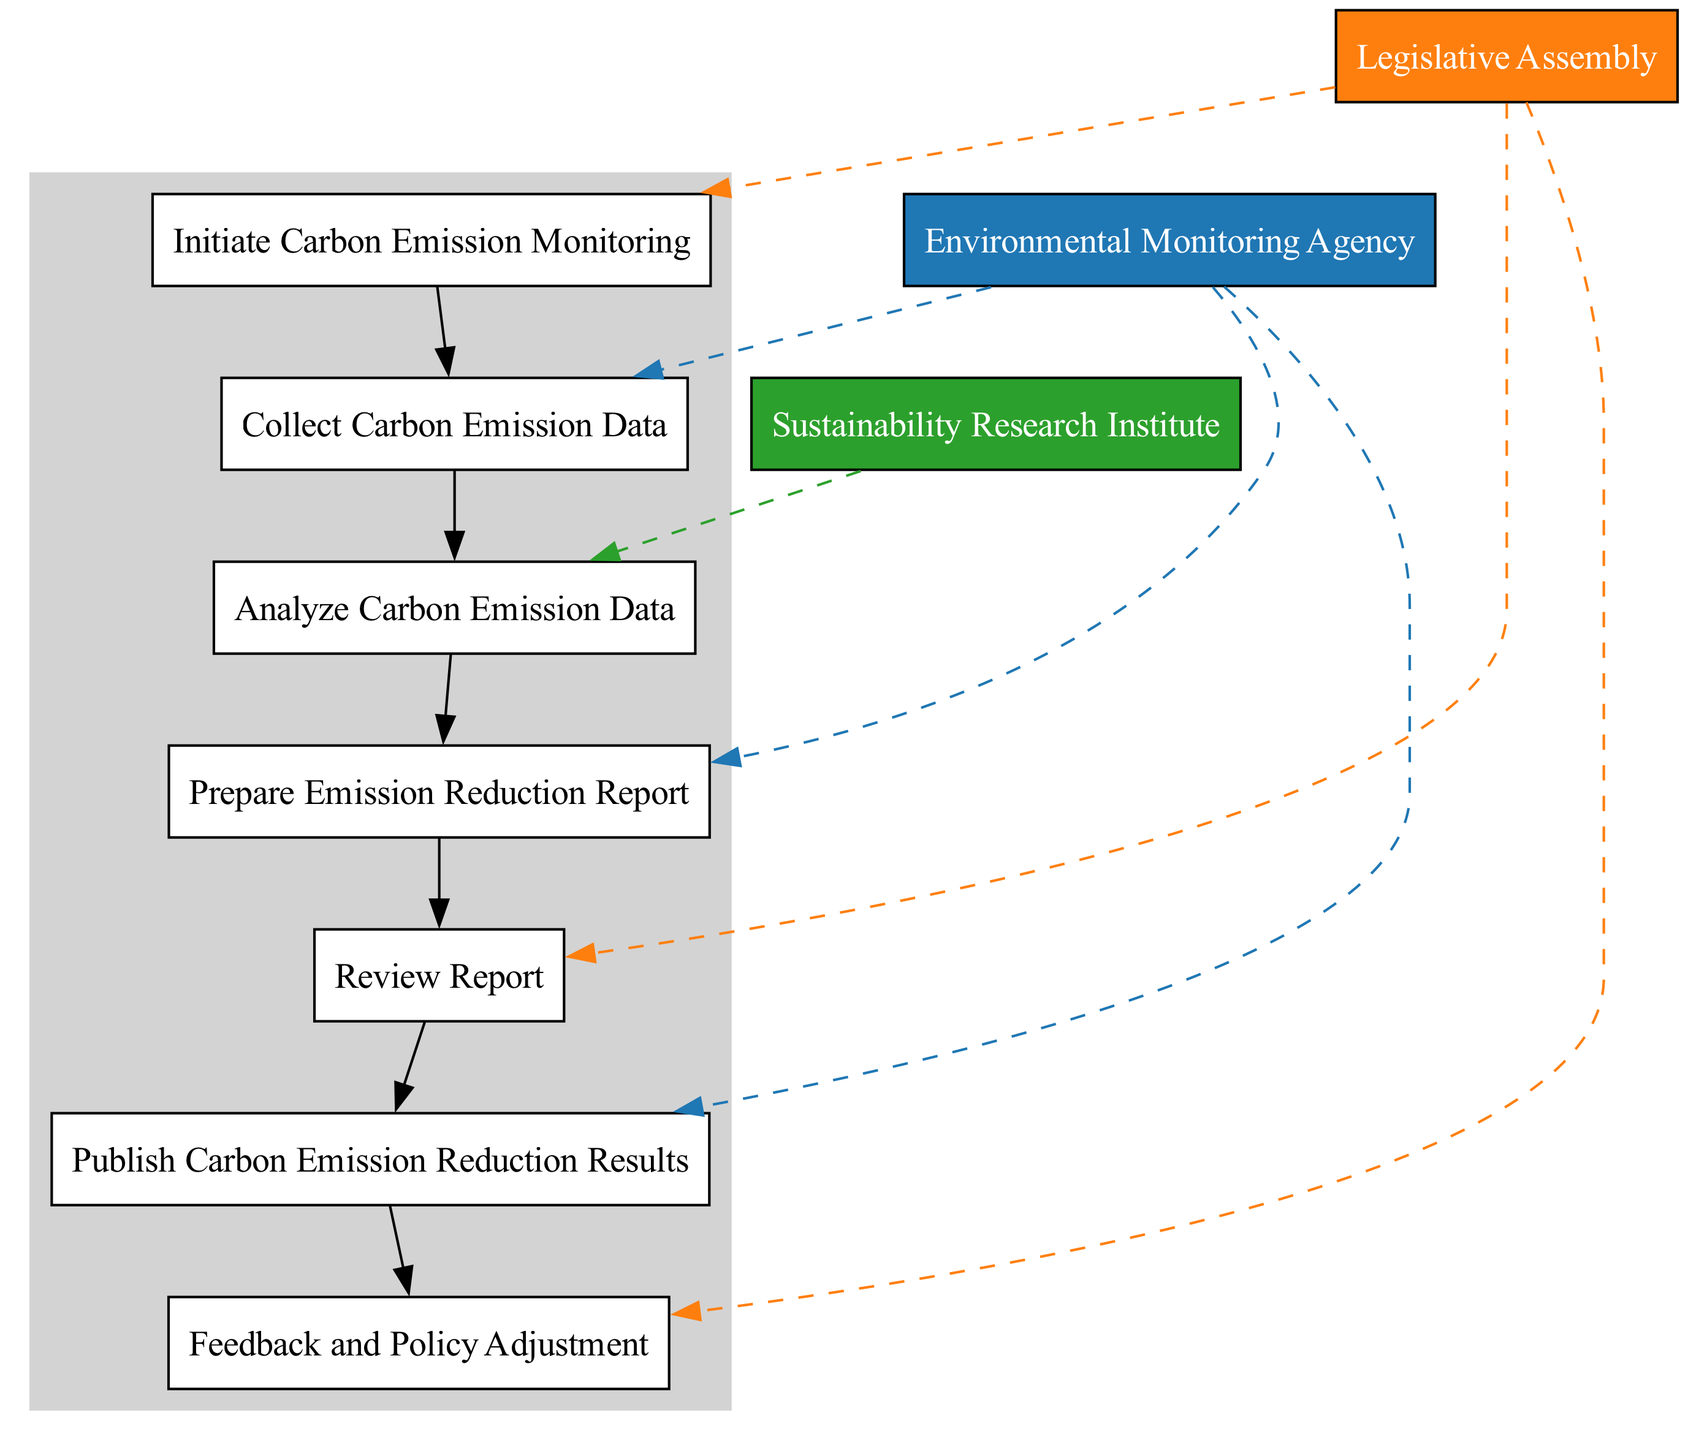What is the first action in the sequence? The first action listed is "Initiate Carbon Emission Monitoring". It appears at the top of the sequence diagram, indicating that it is the starting point of the process.
Answer: Initiate Carbon Emission Monitoring How many actions are included in this process? By counting the elements listed in the diagram, there are a total of 6 actions: Initiate Carbon Emission Monitoring, Collect Carbon Emission Data, Analyze Carbon Emission Data, Prepare Emission Reduction Report, Review Report, and Publish Carbon Emission Reduction Results, along with Feedback and Policy Adjustment.
Answer: 7 Which actor is responsible for analyzing the carbon emission data? Referring to the diagram, the actor associated with "Analyze Carbon Emission Data" is the "Sustainability Research Institute." This indicates that this actor has the responsibility for this specific task.
Answer: Sustainability Research Institute What follows the "Collect Carbon Emission Data" action? The action immediately following "Collect Carbon Emission Data" in the sequence is "Analyze Carbon Emission Data." This indicates the next logical step in the monitoring process.
Answer: Analyze Carbon Emission Data Which actor publishes the carbon emission reduction results? The diagram clearly shows that the "Environmental Monitoring Agency" is responsible for publishing the carbon emission reduction results, according to the action "Publish Carbon Emission Reduction Results".
Answer: Environmental Monitoring Agency What is the purpose of the "Feedback and Policy Adjustment" action? "Feedback and Policy Adjustment" indicates that after reviewing the report, the Legislative Assembly can adjust policies based on feedback received, thus connecting the reporting phase to possible policy adaptations.
Answer: Policy adjustment based on feedback How many actors are involved in the carbon emission monitoring process? There are three distinct actors involved: "Legislative Assembly," "Environmental Monitoring Agency," and "Sustainability Research Institute," as identified from their roles in the different actions.
Answer: 3 